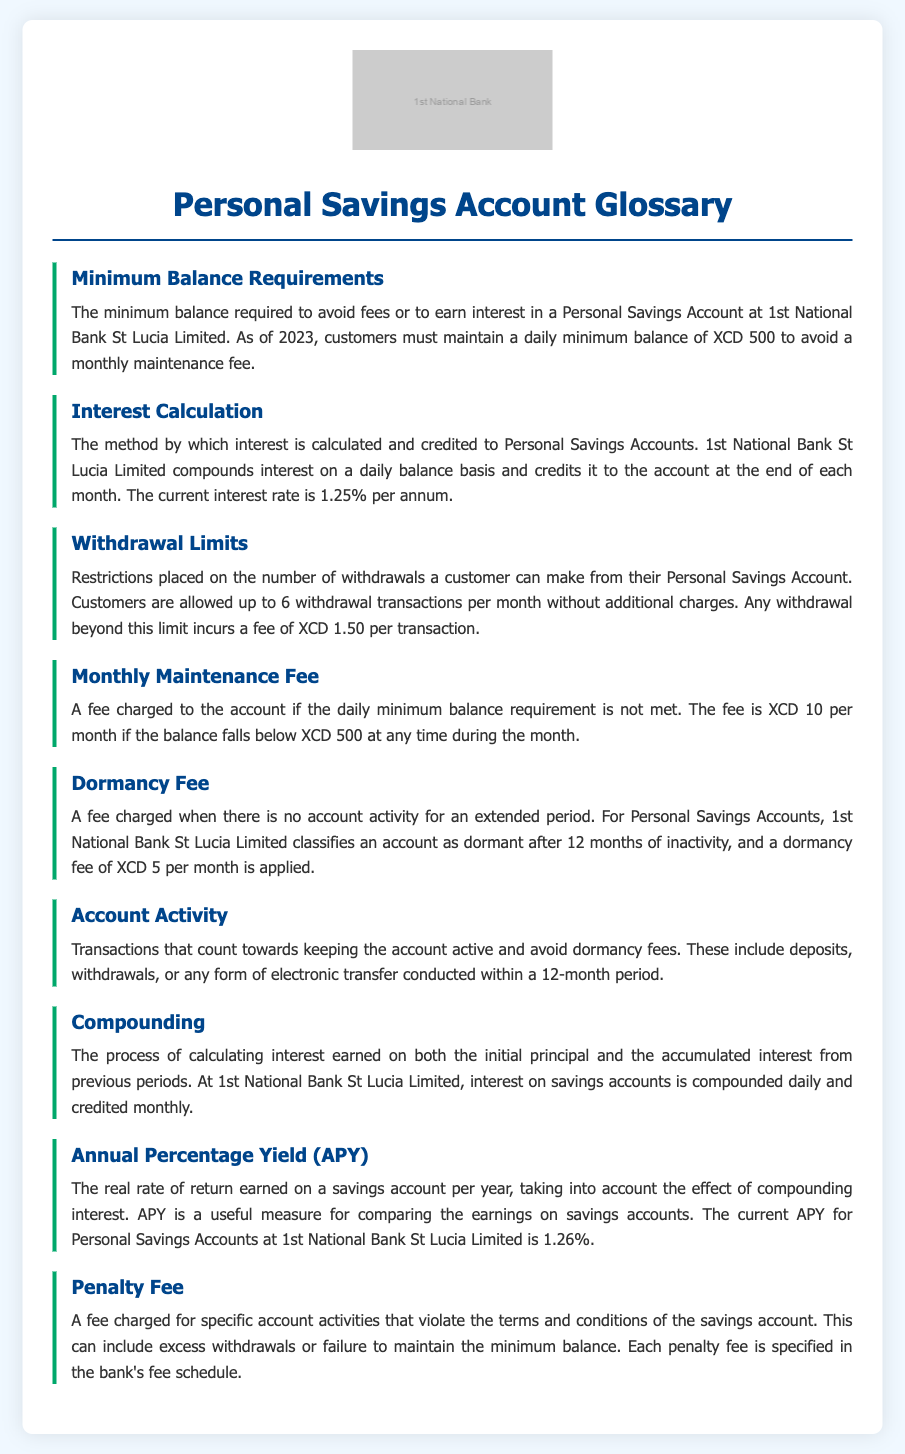What is the minimum balance required to avoid fees? The minimum balance to avoid fees in a Personal Savings Account is stated in the document, which is XCD 500.
Answer: XCD 500 How often is interest credited to the account? The document specifies that interest is credited at the end of each month for Personal Savings Accounts.
Answer: Monthly What is the current interest rate for Personal Savings Accounts? The document mentions that the current interest rate is provided, which is 1.25% per annum.
Answer: 1.25% How many withdrawal transactions are allowed per month without fees? The document states that customers are permitted up to 6 withdrawal transactions without incurring additional charges.
Answer: 6 What is the fee for exceeding the withdrawal limit? The document includes information about exceeding the withdrawal limit, which incurs a fee of XCD 1.50 per transaction.
Answer: XCD 1.50 What happens if the minimum balance requirement is not met? The document indicates that a monthly maintenance fee is charged if the minimum balance requirement is not fulfilled.
Answer: Monthly maintenance fee What is classified as account dormancy? The document specifies that an account is classified as dormant after 12 months of inactivity.
Answer: 12 months How is the Annual Percentage Yield (APY) defined? The document defines APY as the real rate of return earned on a savings account per year, factoring in compounding interest.
Answer: Real rate of return What is the dormancy fee per month after the account is classified as dormant? The document states that a dormancy fee of XCD 5 per month is applied after the account is classified as dormant.
Answer: XCD 5 